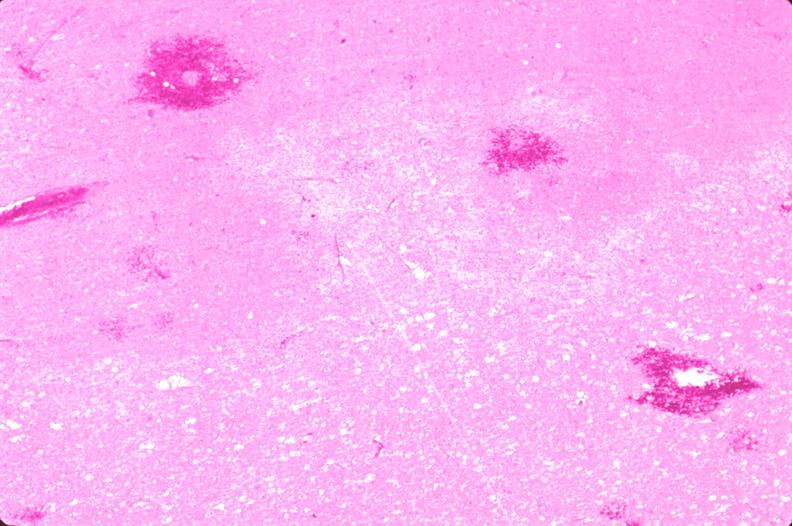why does this image show brain, infarct?
Answer the question using a single word or phrase. Due to ruptured saccular aneurysm and thrombosis of right middle cerebral artery 